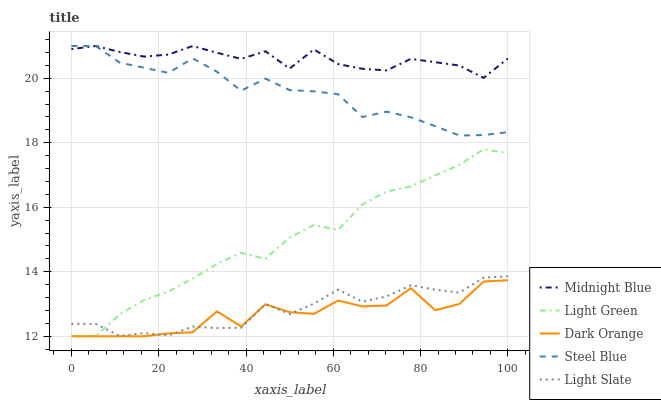Does Dark Orange have the minimum area under the curve?
Answer yes or no. Yes. Does Midnight Blue have the maximum area under the curve?
Answer yes or no. Yes. Does Midnight Blue have the minimum area under the curve?
Answer yes or no. No. Does Dark Orange have the maximum area under the curve?
Answer yes or no. No. Is Light Green the smoothest?
Answer yes or no. Yes. Is Dark Orange the roughest?
Answer yes or no. Yes. Is Midnight Blue the smoothest?
Answer yes or no. No. Is Midnight Blue the roughest?
Answer yes or no. No. Does Dark Orange have the lowest value?
Answer yes or no. Yes. Does Midnight Blue have the lowest value?
Answer yes or no. No. Does Steel Blue have the highest value?
Answer yes or no. Yes. Does Dark Orange have the highest value?
Answer yes or no. No. Is Light Slate less than Midnight Blue?
Answer yes or no. Yes. Is Steel Blue greater than Light Slate?
Answer yes or no. Yes. Does Steel Blue intersect Midnight Blue?
Answer yes or no. Yes. Is Steel Blue less than Midnight Blue?
Answer yes or no. No. Is Steel Blue greater than Midnight Blue?
Answer yes or no. No. Does Light Slate intersect Midnight Blue?
Answer yes or no. No. 